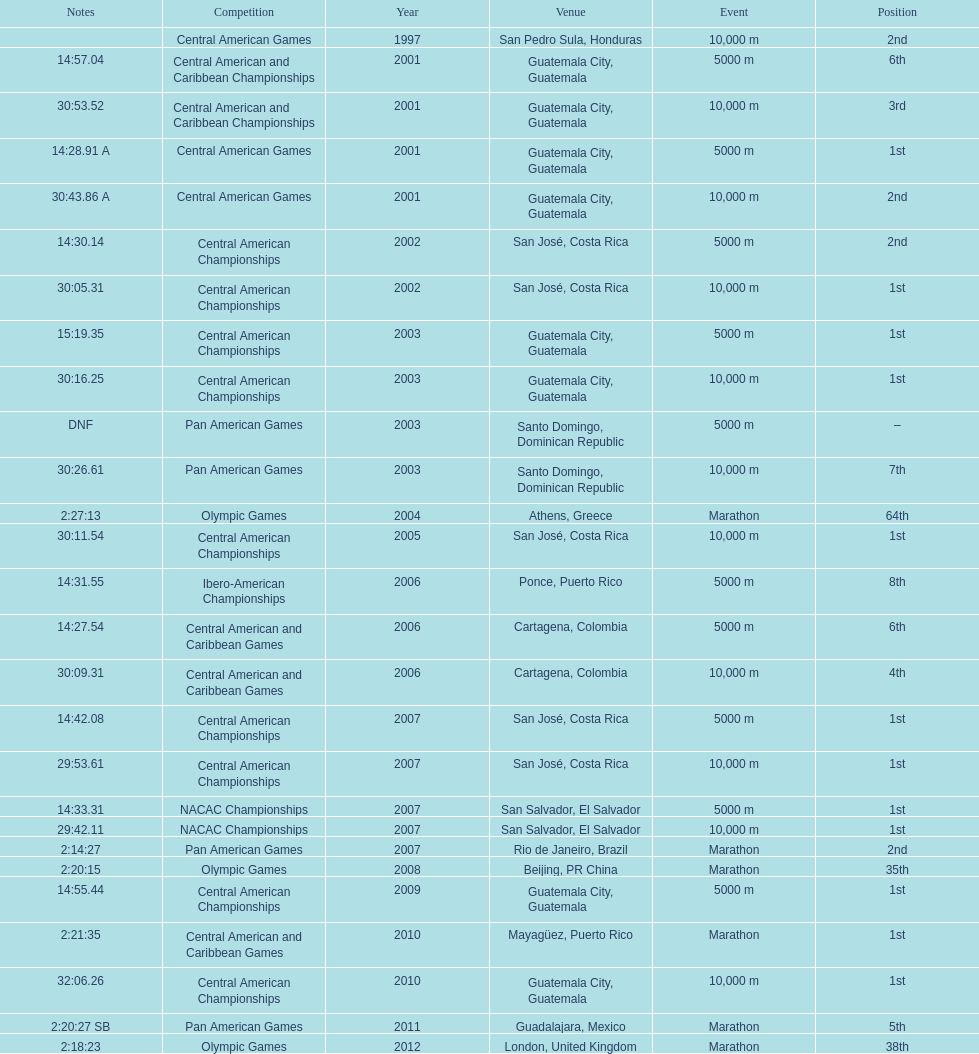The central american championships and what other competition occurred in 2010? Central American and Caribbean Games. 